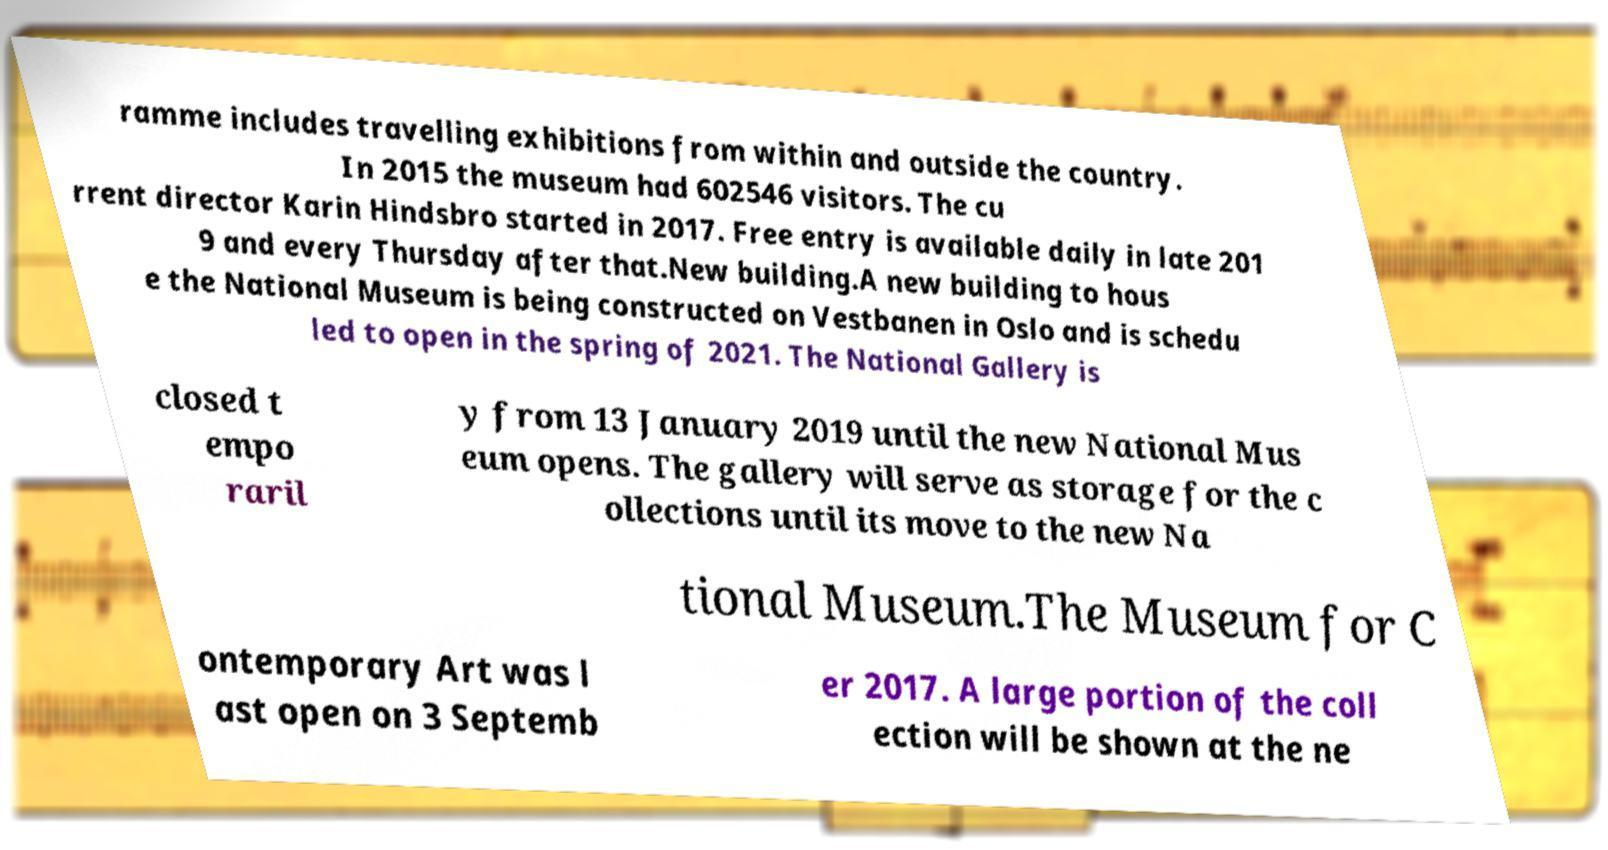Can you accurately transcribe the text from the provided image for me? ramme includes travelling exhibitions from within and outside the country. In 2015 the museum had 602546 visitors. The cu rrent director Karin Hindsbro started in 2017. Free entry is available daily in late 201 9 and every Thursday after that.New building.A new building to hous e the National Museum is being constructed on Vestbanen in Oslo and is schedu led to open in the spring of 2021. The National Gallery is closed t empo raril y from 13 January 2019 until the new National Mus eum opens. The gallery will serve as storage for the c ollections until its move to the new Na tional Museum.The Museum for C ontemporary Art was l ast open on 3 Septemb er 2017. A large portion of the coll ection will be shown at the ne 